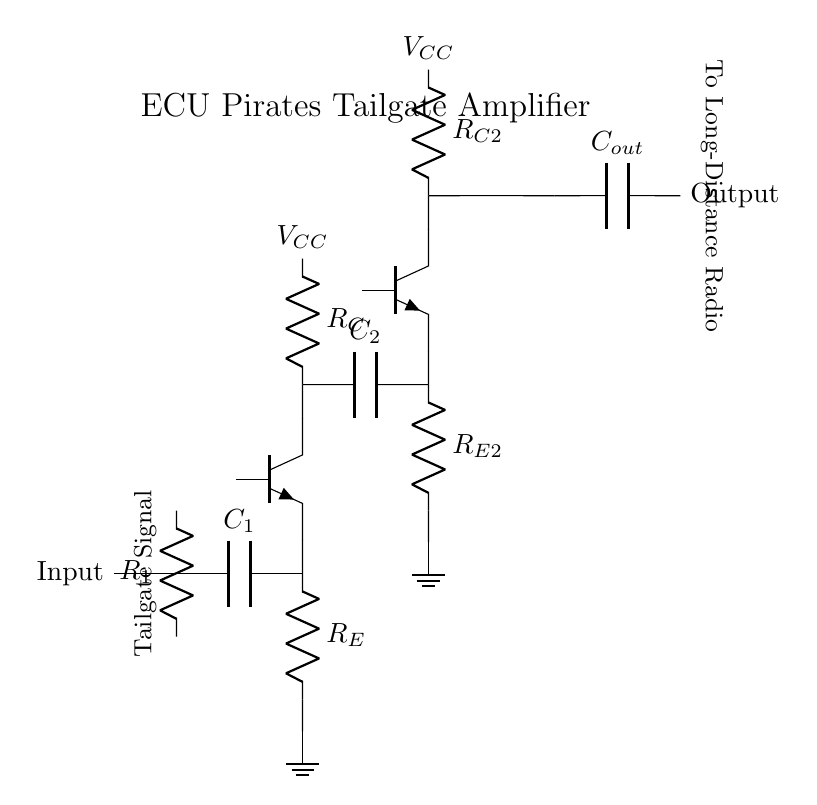What type of transistors are used in this circuit? The circuit contains two Tnpn transistors, as indicated by the labels on the components.
Answer: Tnpn What are the values of the resistors in the first stage amplifier? The first stage amplifier includes a resistor labeled R1 and another labeled R_E, but their specific values are not provided in the diagram.
Answer: R1 and R_E What is the purpose of capacitor C1 in the circuit? Capacitor C1 is used for coupling, allowing AC signals to pass while blocking DC components. This is typically essential in amplifying circuits to separate stages without affecting the DC biasing.
Answer: Coupling How many stages of amplification are present? The circuit diagram depicts two stages of amplification, as seen by the two Tnpn transistors labeled Q1 and Q2. Each stage amplifies the signal further.
Answer: Two What is the voltage used for powering the amplifiers? The circuit shows a voltage labeled V_CC connected to the collectors of both amplifiers, indicating the power supply for the circuit.
Answer: V_CC What is the final output of the circuit? The output is shown to be connected through capacitor C_out, which is designed for the final signal to go to the long-distance radio communication system.
Answer: Long-Distance Radio What is the primary function of this circuit? The primary function of this circuit is to amplify a signal for long-distance communication, particularly for tailgating purposes, as indicated in the circuit label.
Answer: Signal Amplifier 